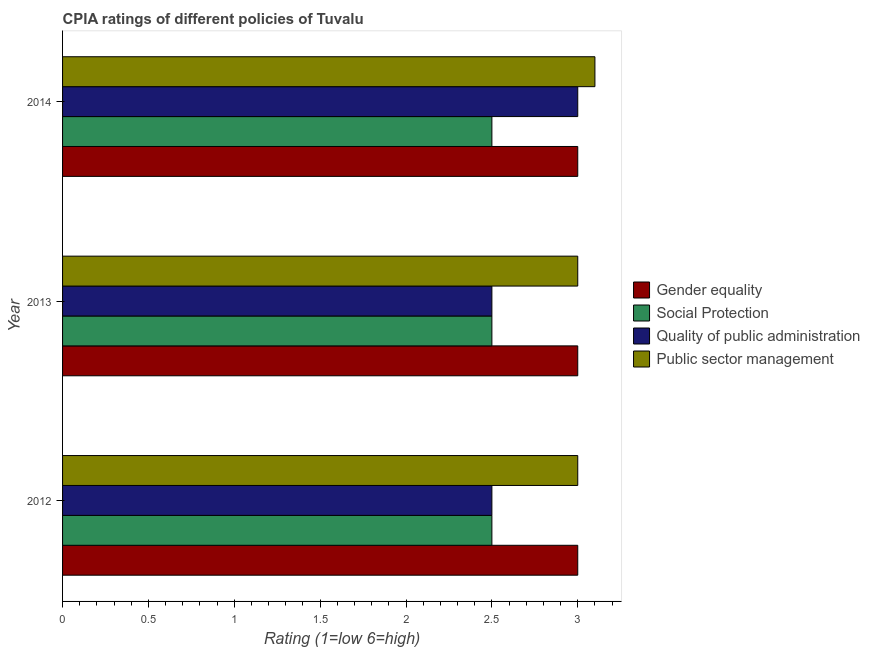Are the number of bars on each tick of the Y-axis equal?
Make the answer very short. Yes. How many bars are there on the 3rd tick from the top?
Make the answer very short. 4. How many bars are there on the 2nd tick from the bottom?
Provide a short and direct response. 4. What is the cpia rating of gender equality in 2014?
Provide a succinct answer. 3. In which year was the cpia rating of gender equality maximum?
Keep it short and to the point. 2012. In which year was the cpia rating of gender equality minimum?
Give a very brief answer. 2012. What is the total cpia rating of gender equality in the graph?
Your answer should be very brief. 9. What is the difference between the cpia rating of gender equality in 2013 and that in 2014?
Provide a short and direct response. 0. What is the average cpia rating of social protection per year?
Keep it short and to the point. 2.5. In how many years, is the cpia rating of social protection greater than 0.30000000000000004 ?
Ensure brevity in your answer.  3. Is the cpia rating of quality of public administration in 2012 less than that in 2013?
Provide a short and direct response. No. What is the difference between the highest and the second highest cpia rating of gender equality?
Keep it short and to the point. 0. In how many years, is the cpia rating of gender equality greater than the average cpia rating of gender equality taken over all years?
Your answer should be compact. 0. Is the sum of the cpia rating of quality of public administration in 2012 and 2013 greater than the maximum cpia rating of social protection across all years?
Provide a succinct answer. Yes. What does the 2nd bar from the top in 2013 represents?
Provide a short and direct response. Quality of public administration. What does the 4th bar from the bottom in 2012 represents?
Offer a terse response. Public sector management. Is it the case that in every year, the sum of the cpia rating of gender equality and cpia rating of social protection is greater than the cpia rating of quality of public administration?
Your answer should be compact. Yes. How many bars are there?
Provide a short and direct response. 12. Are all the bars in the graph horizontal?
Ensure brevity in your answer.  Yes. What is the difference between two consecutive major ticks on the X-axis?
Your answer should be very brief. 0.5. Are the values on the major ticks of X-axis written in scientific E-notation?
Ensure brevity in your answer.  No. Does the graph contain grids?
Your answer should be compact. No. How many legend labels are there?
Offer a very short reply. 4. What is the title of the graph?
Your answer should be compact. CPIA ratings of different policies of Tuvalu. What is the label or title of the X-axis?
Your answer should be compact. Rating (1=low 6=high). What is the Rating (1=low 6=high) of Public sector management in 2012?
Give a very brief answer. 3. What is the Rating (1=low 6=high) of Social Protection in 2013?
Provide a succinct answer. 2.5. What is the Rating (1=low 6=high) in Quality of public administration in 2013?
Provide a succinct answer. 2.5. What is the Rating (1=low 6=high) of Public sector management in 2013?
Provide a succinct answer. 3. What is the Rating (1=low 6=high) in Social Protection in 2014?
Provide a short and direct response. 2.5. Across all years, what is the maximum Rating (1=low 6=high) in Gender equality?
Your answer should be compact. 3. Across all years, what is the maximum Rating (1=low 6=high) in Social Protection?
Make the answer very short. 2.5. Across all years, what is the maximum Rating (1=low 6=high) in Public sector management?
Provide a succinct answer. 3.1. Across all years, what is the minimum Rating (1=low 6=high) of Gender equality?
Your answer should be very brief. 3. Across all years, what is the minimum Rating (1=low 6=high) in Social Protection?
Provide a succinct answer. 2.5. What is the total Rating (1=low 6=high) in Gender equality in the graph?
Ensure brevity in your answer.  9. What is the total Rating (1=low 6=high) in Social Protection in the graph?
Your answer should be compact. 7.5. What is the total Rating (1=low 6=high) of Public sector management in the graph?
Provide a succinct answer. 9.1. What is the difference between the Rating (1=low 6=high) in Gender equality in 2012 and that in 2013?
Offer a terse response. 0. What is the difference between the Rating (1=low 6=high) of Quality of public administration in 2012 and that in 2013?
Ensure brevity in your answer.  0. What is the difference between the Rating (1=low 6=high) in Gender equality in 2012 and that in 2014?
Give a very brief answer. 0. What is the difference between the Rating (1=low 6=high) of Public sector management in 2012 and that in 2014?
Provide a short and direct response. -0.1. What is the difference between the Rating (1=low 6=high) in Gender equality in 2013 and that in 2014?
Your answer should be compact. 0. What is the difference between the Rating (1=low 6=high) of Gender equality in 2012 and the Rating (1=low 6=high) of Social Protection in 2013?
Your response must be concise. 0.5. What is the difference between the Rating (1=low 6=high) of Gender equality in 2012 and the Rating (1=low 6=high) of Quality of public administration in 2013?
Provide a short and direct response. 0.5. What is the difference between the Rating (1=low 6=high) of Gender equality in 2012 and the Rating (1=low 6=high) of Public sector management in 2013?
Provide a short and direct response. 0. What is the difference between the Rating (1=low 6=high) in Social Protection in 2012 and the Rating (1=low 6=high) in Public sector management in 2013?
Offer a very short reply. -0.5. What is the difference between the Rating (1=low 6=high) in Quality of public administration in 2012 and the Rating (1=low 6=high) in Public sector management in 2013?
Offer a terse response. -0.5. What is the difference between the Rating (1=low 6=high) in Gender equality in 2012 and the Rating (1=low 6=high) in Social Protection in 2014?
Your response must be concise. 0.5. What is the difference between the Rating (1=low 6=high) of Social Protection in 2012 and the Rating (1=low 6=high) of Quality of public administration in 2014?
Your answer should be compact. -0.5. What is the difference between the Rating (1=low 6=high) in Social Protection in 2012 and the Rating (1=low 6=high) in Public sector management in 2014?
Offer a very short reply. -0.6. What is the difference between the Rating (1=low 6=high) in Quality of public administration in 2013 and the Rating (1=low 6=high) in Public sector management in 2014?
Make the answer very short. -0.6. What is the average Rating (1=low 6=high) of Gender equality per year?
Your answer should be compact. 3. What is the average Rating (1=low 6=high) of Social Protection per year?
Your answer should be very brief. 2.5. What is the average Rating (1=low 6=high) of Quality of public administration per year?
Offer a very short reply. 2.67. What is the average Rating (1=low 6=high) in Public sector management per year?
Ensure brevity in your answer.  3.03. In the year 2012, what is the difference between the Rating (1=low 6=high) of Gender equality and Rating (1=low 6=high) of Social Protection?
Offer a very short reply. 0.5. In the year 2012, what is the difference between the Rating (1=low 6=high) of Gender equality and Rating (1=low 6=high) of Public sector management?
Make the answer very short. 0. In the year 2012, what is the difference between the Rating (1=low 6=high) of Social Protection and Rating (1=low 6=high) of Public sector management?
Make the answer very short. -0.5. In the year 2012, what is the difference between the Rating (1=low 6=high) of Quality of public administration and Rating (1=low 6=high) of Public sector management?
Keep it short and to the point. -0.5. In the year 2013, what is the difference between the Rating (1=low 6=high) in Gender equality and Rating (1=low 6=high) in Social Protection?
Your answer should be compact. 0.5. In the year 2013, what is the difference between the Rating (1=low 6=high) of Gender equality and Rating (1=low 6=high) of Quality of public administration?
Keep it short and to the point. 0.5. In the year 2013, what is the difference between the Rating (1=low 6=high) in Gender equality and Rating (1=low 6=high) in Public sector management?
Provide a succinct answer. 0. In the year 2013, what is the difference between the Rating (1=low 6=high) in Social Protection and Rating (1=low 6=high) in Public sector management?
Give a very brief answer. -0.5. In the year 2014, what is the difference between the Rating (1=low 6=high) in Gender equality and Rating (1=low 6=high) in Social Protection?
Your answer should be very brief. 0.5. In the year 2014, what is the difference between the Rating (1=low 6=high) in Gender equality and Rating (1=low 6=high) in Public sector management?
Your answer should be compact. -0.1. In the year 2014, what is the difference between the Rating (1=low 6=high) of Social Protection and Rating (1=low 6=high) of Quality of public administration?
Your response must be concise. -0.5. In the year 2014, what is the difference between the Rating (1=low 6=high) in Social Protection and Rating (1=low 6=high) in Public sector management?
Offer a terse response. -0.6. In the year 2014, what is the difference between the Rating (1=low 6=high) of Quality of public administration and Rating (1=low 6=high) of Public sector management?
Give a very brief answer. -0.1. What is the ratio of the Rating (1=low 6=high) of Gender equality in 2012 to that in 2013?
Your answer should be compact. 1. What is the ratio of the Rating (1=low 6=high) of Quality of public administration in 2012 to that in 2013?
Offer a very short reply. 1. What is the ratio of the Rating (1=low 6=high) of Gender equality in 2012 to that in 2014?
Provide a succinct answer. 1. What is the ratio of the Rating (1=low 6=high) of Public sector management in 2012 to that in 2014?
Offer a very short reply. 0.97. What is the ratio of the Rating (1=low 6=high) in Public sector management in 2013 to that in 2014?
Make the answer very short. 0.97. What is the difference between the highest and the second highest Rating (1=low 6=high) of Gender equality?
Provide a succinct answer. 0. What is the difference between the highest and the second highest Rating (1=low 6=high) in Social Protection?
Your response must be concise. 0. What is the difference between the highest and the second highest Rating (1=low 6=high) in Public sector management?
Make the answer very short. 0.1. What is the difference between the highest and the lowest Rating (1=low 6=high) of Gender equality?
Offer a very short reply. 0. What is the difference between the highest and the lowest Rating (1=low 6=high) of Social Protection?
Your answer should be compact. 0. What is the difference between the highest and the lowest Rating (1=low 6=high) in Quality of public administration?
Offer a very short reply. 0.5. What is the difference between the highest and the lowest Rating (1=low 6=high) in Public sector management?
Provide a succinct answer. 0.1. 